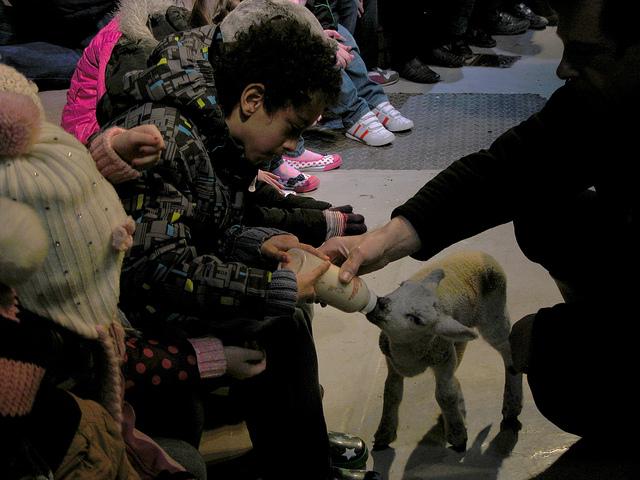What is he using to nurse the animal?
Keep it brief. Bottle. How many animals can be seen?
Write a very short answer. 1. What is the pink object laying on the ground?
Concise answer only. Shoes. Are they going for a walk?
Keep it brief. No. Why is he feeding the goat?
Answer briefly. Hungry. 